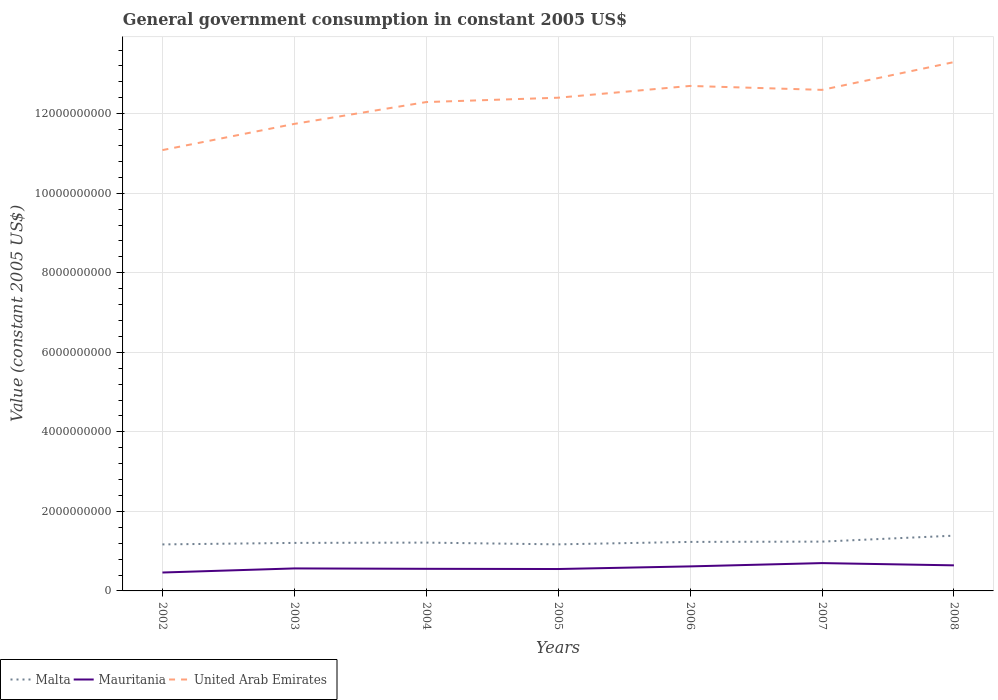Does the line corresponding to Malta intersect with the line corresponding to United Arab Emirates?
Make the answer very short. No. Across all years, what is the maximum government conusmption in Mauritania?
Offer a terse response. 4.63e+08. In which year was the government conusmption in United Arab Emirates maximum?
Your response must be concise. 2002. What is the total government conusmption in Mauritania in the graph?
Keep it short and to the point. 9.71e+06. What is the difference between the highest and the second highest government conusmption in United Arab Emirates?
Ensure brevity in your answer.  2.21e+09. What is the difference between the highest and the lowest government conusmption in Malta?
Ensure brevity in your answer.  3. Is the government conusmption in United Arab Emirates strictly greater than the government conusmption in Malta over the years?
Ensure brevity in your answer.  No. How many lines are there?
Provide a succinct answer. 3. Are the values on the major ticks of Y-axis written in scientific E-notation?
Offer a very short reply. No. Where does the legend appear in the graph?
Provide a short and direct response. Bottom left. How many legend labels are there?
Your answer should be compact. 3. How are the legend labels stacked?
Ensure brevity in your answer.  Horizontal. What is the title of the graph?
Give a very brief answer. General government consumption in constant 2005 US$. Does "Israel" appear as one of the legend labels in the graph?
Make the answer very short. No. What is the label or title of the Y-axis?
Make the answer very short. Value (constant 2005 US$). What is the Value (constant 2005 US$) of Malta in 2002?
Offer a very short reply. 1.17e+09. What is the Value (constant 2005 US$) of Mauritania in 2002?
Your response must be concise. 4.63e+08. What is the Value (constant 2005 US$) in United Arab Emirates in 2002?
Provide a succinct answer. 1.11e+1. What is the Value (constant 2005 US$) of Malta in 2003?
Your response must be concise. 1.21e+09. What is the Value (constant 2005 US$) in Mauritania in 2003?
Keep it short and to the point. 5.66e+08. What is the Value (constant 2005 US$) of United Arab Emirates in 2003?
Offer a terse response. 1.17e+1. What is the Value (constant 2005 US$) in Malta in 2004?
Provide a succinct answer. 1.21e+09. What is the Value (constant 2005 US$) in Mauritania in 2004?
Offer a very short reply. 5.56e+08. What is the Value (constant 2005 US$) of United Arab Emirates in 2004?
Provide a succinct answer. 1.23e+1. What is the Value (constant 2005 US$) in Malta in 2005?
Provide a short and direct response. 1.17e+09. What is the Value (constant 2005 US$) of Mauritania in 2005?
Provide a short and direct response. 5.51e+08. What is the Value (constant 2005 US$) of United Arab Emirates in 2005?
Keep it short and to the point. 1.24e+1. What is the Value (constant 2005 US$) in Malta in 2006?
Keep it short and to the point. 1.23e+09. What is the Value (constant 2005 US$) in Mauritania in 2006?
Your response must be concise. 6.17e+08. What is the Value (constant 2005 US$) in United Arab Emirates in 2006?
Offer a terse response. 1.27e+1. What is the Value (constant 2005 US$) in Malta in 2007?
Give a very brief answer. 1.24e+09. What is the Value (constant 2005 US$) in Mauritania in 2007?
Make the answer very short. 7.00e+08. What is the Value (constant 2005 US$) of United Arab Emirates in 2007?
Make the answer very short. 1.26e+1. What is the Value (constant 2005 US$) in Malta in 2008?
Ensure brevity in your answer.  1.39e+09. What is the Value (constant 2005 US$) of Mauritania in 2008?
Your answer should be very brief. 6.43e+08. What is the Value (constant 2005 US$) of United Arab Emirates in 2008?
Give a very brief answer. 1.33e+1. Across all years, what is the maximum Value (constant 2005 US$) in Malta?
Your answer should be very brief. 1.39e+09. Across all years, what is the maximum Value (constant 2005 US$) in Mauritania?
Ensure brevity in your answer.  7.00e+08. Across all years, what is the maximum Value (constant 2005 US$) of United Arab Emirates?
Give a very brief answer. 1.33e+1. Across all years, what is the minimum Value (constant 2005 US$) in Malta?
Ensure brevity in your answer.  1.17e+09. Across all years, what is the minimum Value (constant 2005 US$) of Mauritania?
Offer a very short reply. 4.63e+08. Across all years, what is the minimum Value (constant 2005 US$) of United Arab Emirates?
Provide a short and direct response. 1.11e+1. What is the total Value (constant 2005 US$) of Malta in the graph?
Your response must be concise. 8.62e+09. What is the total Value (constant 2005 US$) in Mauritania in the graph?
Your response must be concise. 4.09e+09. What is the total Value (constant 2005 US$) of United Arab Emirates in the graph?
Your answer should be very brief. 8.61e+1. What is the difference between the Value (constant 2005 US$) in Malta in 2002 and that in 2003?
Your response must be concise. -3.79e+07. What is the difference between the Value (constant 2005 US$) of Mauritania in 2002 and that in 2003?
Your answer should be compact. -1.03e+08. What is the difference between the Value (constant 2005 US$) of United Arab Emirates in 2002 and that in 2003?
Your answer should be very brief. -6.59e+08. What is the difference between the Value (constant 2005 US$) in Malta in 2002 and that in 2004?
Offer a very short reply. -4.53e+07. What is the difference between the Value (constant 2005 US$) of Mauritania in 2002 and that in 2004?
Give a very brief answer. -9.31e+07. What is the difference between the Value (constant 2005 US$) in United Arab Emirates in 2002 and that in 2004?
Keep it short and to the point. -1.21e+09. What is the difference between the Value (constant 2005 US$) of Malta in 2002 and that in 2005?
Provide a succinct answer. -1.22e+06. What is the difference between the Value (constant 2005 US$) of Mauritania in 2002 and that in 2005?
Keep it short and to the point. -8.77e+07. What is the difference between the Value (constant 2005 US$) in United Arab Emirates in 2002 and that in 2005?
Your answer should be compact. -1.32e+09. What is the difference between the Value (constant 2005 US$) in Malta in 2002 and that in 2006?
Keep it short and to the point. -6.31e+07. What is the difference between the Value (constant 2005 US$) in Mauritania in 2002 and that in 2006?
Offer a very short reply. -1.54e+08. What is the difference between the Value (constant 2005 US$) of United Arab Emirates in 2002 and that in 2006?
Provide a succinct answer. -1.61e+09. What is the difference between the Value (constant 2005 US$) in Malta in 2002 and that in 2007?
Offer a very short reply. -7.02e+07. What is the difference between the Value (constant 2005 US$) of Mauritania in 2002 and that in 2007?
Provide a succinct answer. -2.37e+08. What is the difference between the Value (constant 2005 US$) in United Arab Emirates in 2002 and that in 2007?
Keep it short and to the point. -1.51e+09. What is the difference between the Value (constant 2005 US$) of Malta in 2002 and that in 2008?
Your answer should be compact. -2.20e+08. What is the difference between the Value (constant 2005 US$) in Mauritania in 2002 and that in 2008?
Provide a short and direct response. -1.80e+08. What is the difference between the Value (constant 2005 US$) in United Arab Emirates in 2002 and that in 2008?
Your answer should be very brief. -2.21e+09. What is the difference between the Value (constant 2005 US$) in Malta in 2003 and that in 2004?
Make the answer very short. -7.48e+06. What is the difference between the Value (constant 2005 US$) in Mauritania in 2003 and that in 2004?
Your answer should be very brief. 9.71e+06. What is the difference between the Value (constant 2005 US$) in United Arab Emirates in 2003 and that in 2004?
Make the answer very short. -5.49e+08. What is the difference between the Value (constant 2005 US$) in Malta in 2003 and that in 2005?
Provide a succinct answer. 3.66e+07. What is the difference between the Value (constant 2005 US$) of Mauritania in 2003 and that in 2005?
Give a very brief answer. 1.52e+07. What is the difference between the Value (constant 2005 US$) in United Arab Emirates in 2003 and that in 2005?
Provide a short and direct response. -6.58e+08. What is the difference between the Value (constant 2005 US$) in Malta in 2003 and that in 2006?
Your answer should be compact. -2.52e+07. What is the difference between the Value (constant 2005 US$) in Mauritania in 2003 and that in 2006?
Make the answer very short. -5.08e+07. What is the difference between the Value (constant 2005 US$) in United Arab Emirates in 2003 and that in 2006?
Provide a short and direct response. -9.54e+08. What is the difference between the Value (constant 2005 US$) in Malta in 2003 and that in 2007?
Your response must be concise. -3.24e+07. What is the difference between the Value (constant 2005 US$) of Mauritania in 2003 and that in 2007?
Keep it short and to the point. -1.34e+08. What is the difference between the Value (constant 2005 US$) in United Arab Emirates in 2003 and that in 2007?
Provide a short and direct response. -8.55e+08. What is the difference between the Value (constant 2005 US$) of Malta in 2003 and that in 2008?
Your response must be concise. -1.82e+08. What is the difference between the Value (constant 2005 US$) in Mauritania in 2003 and that in 2008?
Offer a very short reply. -7.74e+07. What is the difference between the Value (constant 2005 US$) in United Arab Emirates in 2003 and that in 2008?
Provide a succinct answer. -1.55e+09. What is the difference between the Value (constant 2005 US$) of Malta in 2004 and that in 2005?
Provide a succinct answer. 4.41e+07. What is the difference between the Value (constant 2005 US$) in Mauritania in 2004 and that in 2005?
Offer a terse response. 5.46e+06. What is the difference between the Value (constant 2005 US$) in United Arab Emirates in 2004 and that in 2005?
Ensure brevity in your answer.  -1.09e+08. What is the difference between the Value (constant 2005 US$) of Malta in 2004 and that in 2006?
Provide a short and direct response. -1.77e+07. What is the difference between the Value (constant 2005 US$) of Mauritania in 2004 and that in 2006?
Your answer should be compact. -6.05e+07. What is the difference between the Value (constant 2005 US$) in United Arab Emirates in 2004 and that in 2006?
Your answer should be compact. -4.06e+08. What is the difference between the Value (constant 2005 US$) of Malta in 2004 and that in 2007?
Provide a short and direct response. -2.49e+07. What is the difference between the Value (constant 2005 US$) of Mauritania in 2004 and that in 2007?
Keep it short and to the point. -1.44e+08. What is the difference between the Value (constant 2005 US$) in United Arab Emirates in 2004 and that in 2007?
Ensure brevity in your answer.  -3.06e+08. What is the difference between the Value (constant 2005 US$) in Malta in 2004 and that in 2008?
Ensure brevity in your answer.  -1.75e+08. What is the difference between the Value (constant 2005 US$) of Mauritania in 2004 and that in 2008?
Give a very brief answer. -8.71e+07. What is the difference between the Value (constant 2005 US$) in United Arab Emirates in 2004 and that in 2008?
Offer a terse response. -1.00e+09. What is the difference between the Value (constant 2005 US$) in Malta in 2005 and that in 2006?
Give a very brief answer. -6.18e+07. What is the difference between the Value (constant 2005 US$) in Mauritania in 2005 and that in 2006?
Make the answer very short. -6.60e+07. What is the difference between the Value (constant 2005 US$) of United Arab Emirates in 2005 and that in 2006?
Provide a short and direct response. -2.96e+08. What is the difference between the Value (constant 2005 US$) of Malta in 2005 and that in 2007?
Keep it short and to the point. -6.90e+07. What is the difference between the Value (constant 2005 US$) in Mauritania in 2005 and that in 2007?
Ensure brevity in your answer.  -1.49e+08. What is the difference between the Value (constant 2005 US$) of United Arab Emirates in 2005 and that in 2007?
Your answer should be very brief. -1.97e+08. What is the difference between the Value (constant 2005 US$) of Malta in 2005 and that in 2008?
Your answer should be very brief. -2.19e+08. What is the difference between the Value (constant 2005 US$) in Mauritania in 2005 and that in 2008?
Provide a short and direct response. -9.26e+07. What is the difference between the Value (constant 2005 US$) of United Arab Emirates in 2005 and that in 2008?
Offer a very short reply. -8.96e+08. What is the difference between the Value (constant 2005 US$) of Malta in 2006 and that in 2007?
Make the answer very short. -7.18e+06. What is the difference between the Value (constant 2005 US$) of Mauritania in 2006 and that in 2007?
Offer a terse response. -8.31e+07. What is the difference between the Value (constant 2005 US$) of United Arab Emirates in 2006 and that in 2007?
Keep it short and to the point. 9.91e+07. What is the difference between the Value (constant 2005 US$) in Malta in 2006 and that in 2008?
Provide a short and direct response. -1.57e+08. What is the difference between the Value (constant 2005 US$) of Mauritania in 2006 and that in 2008?
Give a very brief answer. -2.66e+07. What is the difference between the Value (constant 2005 US$) in United Arab Emirates in 2006 and that in 2008?
Offer a very short reply. -5.99e+08. What is the difference between the Value (constant 2005 US$) of Malta in 2007 and that in 2008?
Provide a succinct answer. -1.50e+08. What is the difference between the Value (constant 2005 US$) in Mauritania in 2007 and that in 2008?
Offer a terse response. 5.65e+07. What is the difference between the Value (constant 2005 US$) in United Arab Emirates in 2007 and that in 2008?
Offer a very short reply. -6.98e+08. What is the difference between the Value (constant 2005 US$) of Malta in 2002 and the Value (constant 2005 US$) of Mauritania in 2003?
Your answer should be compact. 6.04e+08. What is the difference between the Value (constant 2005 US$) in Malta in 2002 and the Value (constant 2005 US$) in United Arab Emirates in 2003?
Keep it short and to the point. -1.06e+1. What is the difference between the Value (constant 2005 US$) of Mauritania in 2002 and the Value (constant 2005 US$) of United Arab Emirates in 2003?
Offer a very short reply. -1.13e+1. What is the difference between the Value (constant 2005 US$) in Malta in 2002 and the Value (constant 2005 US$) in Mauritania in 2004?
Make the answer very short. 6.13e+08. What is the difference between the Value (constant 2005 US$) in Malta in 2002 and the Value (constant 2005 US$) in United Arab Emirates in 2004?
Make the answer very short. -1.11e+1. What is the difference between the Value (constant 2005 US$) in Mauritania in 2002 and the Value (constant 2005 US$) in United Arab Emirates in 2004?
Your response must be concise. -1.18e+1. What is the difference between the Value (constant 2005 US$) in Malta in 2002 and the Value (constant 2005 US$) in Mauritania in 2005?
Ensure brevity in your answer.  6.19e+08. What is the difference between the Value (constant 2005 US$) in Malta in 2002 and the Value (constant 2005 US$) in United Arab Emirates in 2005?
Give a very brief answer. -1.12e+1. What is the difference between the Value (constant 2005 US$) in Mauritania in 2002 and the Value (constant 2005 US$) in United Arab Emirates in 2005?
Your answer should be very brief. -1.19e+1. What is the difference between the Value (constant 2005 US$) of Malta in 2002 and the Value (constant 2005 US$) of Mauritania in 2006?
Give a very brief answer. 5.53e+08. What is the difference between the Value (constant 2005 US$) of Malta in 2002 and the Value (constant 2005 US$) of United Arab Emirates in 2006?
Give a very brief answer. -1.15e+1. What is the difference between the Value (constant 2005 US$) of Mauritania in 2002 and the Value (constant 2005 US$) of United Arab Emirates in 2006?
Provide a succinct answer. -1.22e+1. What is the difference between the Value (constant 2005 US$) in Malta in 2002 and the Value (constant 2005 US$) in Mauritania in 2007?
Your answer should be compact. 4.70e+08. What is the difference between the Value (constant 2005 US$) of Malta in 2002 and the Value (constant 2005 US$) of United Arab Emirates in 2007?
Your answer should be compact. -1.14e+1. What is the difference between the Value (constant 2005 US$) of Mauritania in 2002 and the Value (constant 2005 US$) of United Arab Emirates in 2007?
Keep it short and to the point. -1.21e+1. What is the difference between the Value (constant 2005 US$) in Malta in 2002 and the Value (constant 2005 US$) in Mauritania in 2008?
Your answer should be compact. 5.26e+08. What is the difference between the Value (constant 2005 US$) in Malta in 2002 and the Value (constant 2005 US$) in United Arab Emirates in 2008?
Provide a succinct answer. -1.21e+1. What is the difference between the Value (constant 2005 US$) of Mauritania in 2002 and the Value (constant 2005 US$) of United Arab Emirates in 2008?
Provide a succinct answer. -1.28e+1. What is the difference between the Value (constant 2005 US$) in Malta in 2003 and the Value (constant 2005 US$) in Mauritania in 2004?
Your response must be concise. 6.51e+08. What is the difference between the Value (constant 2005 US$) of Malta in 2003 and the Value (constant 2005 US$) of United Arab Emirates in 2004?
Ensure brevity in your answer.  -1.11e+1. What is the difference between the Value (constant 2005 US$) in Mauritania in 2003 and the Value (constant 2005 US$) in United Arab Emirates in 2004?
Give a very brief answer. -1.17e+1. What is the difference between the Value (constant 2005 US$) of Malta in 2003 and the Value (constant 2005 US$) of Mauritania in 2005?
Make the answer very short. 6.57e+08. What is the difference between the Value (constant 2005 US$) in Malta in 2003 and the Value (constant 2005 US$) in United Arab Emirates in 2005?
Your answer should be very brief. -1.12e+1. What is the difference between the Value (constant 2005 US$) in Mauritania in 2003 and the Value (constant 2005 US$) in United Arab Emirates in 2005?
Make the answer very short. -1.18e+1. What is the difference between the Value (constant 2005 US$) of Malta in 2003 and the Value (constant 2005 US$) of Mauritania in 2006?
Provide a succinct answer. 5.91e+08. What is the difference between the Value (constant 2005 US$) of Malta in 2003 and the Value (constant 2005 US$) of United Arab Emirates in 2006?
Your answer should be very brief. -1.15e+1. What is the difference between the Value (constant 2005 US$) of Mauritania in 2003 and the Value (constant 2005 US$) of United Arab Emirates in 2006?
Give a very brief answer. -1.21e+1. What is the difference between the Value (constant 2005 US$) of Malta in 2003 and the Value (constant 2005 US$) of Mauritania in 2007?
Make the answer very short. 5.08e+08. What is the difference between the Value (constant 2005 US$) in Malta in 2003 and the Value (constant 2005 US$) in United Arab Emirates in 2007?
Keep it short and to the point. -1.14e+1. What is the difference between the Value (constant 2005 US$) in Mauritania in 2003 and the Value (constant 2005 US$) in United Arab Emirates in 2007?
Ensure brevity in your answer.  -1.20e+1. What is the difference between the Value (constant 2005 US$) of Malta in 2003 and the Value (constant 2005 US$) of Mauritania in 2008?
Provide a succinct answer. 5.64e+08. What is the difference between the Value (constant 2005 US$) in Malta in 2003 and the Value (constant 2005 US$) in United Arab Emirates in 2008?
Give a very brief answer. -1.21e+1. What is the difference between the Value (constant 2005 US$) in Mauritania in 2003 and the Value (constant 2005 US$) in United Arab Emirates in 2008?
Your answer should be very brief. -1.27e+1. What is the difference between the Value (constant 2005 US$) of Malta in 2004 and the Value (constant 2005 US$) of Mauritania in 2005?
Your answer should be compact. 6.64e+08. What is the difference between the Value (constant 2005 US$) of Malta in 2004 and the Value (constant 2005 US$) of United Arab Emirates in 2005?
Make the answer very short. -1.12e+1. What is the difference between the Value (constant 2005 US$) of Mauritania in 2004 and the Value (constant 2005 US$) of United Arab Emirates in 2005?
Make the answer very short. -1.18e+1. What is the difference between the Value (constant 2005 US$) of Malta in 2004 and the Value (constant 2005 US$) of Mauritania in 2006?
Make the answer very short. 5.98e+08. What is the difference between the Value (constant 2005 US$) in Malta in 2004 and the Value (constant 2005 US$) in United Arab Emirates in 2006?
Offer a terse response. -1.15e+1. What is the difference between the Value (constant 2005 US$) in Mauritania in 2004 and the Value (constant 2005 US$) in United Arab Emirates in 2006?
Give a very brief answer. -1.21e+1. What is the difference between the Value (constant 2005 US$) of Malta in 2004 and the Value (constant 2005 US$) of Mauritania in 2007?
Make the answer very short. 5.15e+08. What is the difference between the Value (constant 2005 US$) of Malta in 2004 and the Value (constant 2005 US$) of United Arab Emirates in 2007?
Make the answer very short. -1.14e+1. What is the difference between the Value (constant 2005 US$) in Mauritania in 2004 and the Value (constant 2005 US$) in United Arab Emirates in 2007?
Provide a short and direct response. -1.20e+1. What is the difference between the Value (constant 2005 US$) of Malta in 2004 and the Value (constant 2005 US$) of Mauritania in 2008?
Your answer should be compact. 5.72e+08. What is the difference between the Value (constant 2005 US$) of Malta in 2004 and the Value (constant 2005 US$) of United Arab Emirates in 2008?
Make the answer very short. -1.21e+1. What is the difference between the Value (constant 2005 US$) in Mauritania in 2004 and the Value (constant 2005 US$) in United Arab Emirates in 2008?
Offer a terse response. -1.27e+1. What is the difference between the Value (constant 2005 US$) of Malta in 2005 and the Value (constant 2005 US$) of Mauritania in 2006?
Give a very brief answer. 5.54e+08. What is the difference between the Value (constant 2005 US$) of Malta in 2005 and the Value (constant 2005 US$) of United Arab Emirates in 2006?
Your response must be concise. -1.15e+1. What is the difference between the Value (constant 2005 US$) in Mauritania in 2005 and the Value (constant 2005 US$) in United Arab Emirates in 2006?
Keep it short and to the point. -1.21e+1. What is the difference between the Value (constant 2005 US$) of Malta in 2005 and the Value (constant 2005 US$) of Mauritania in 2007?
Keep it short and to the point. 4.71e+08. What is the difference between the Value (constant 2005 US$) of Malta in 2005 and the Value (constant 2005 US$) of United Arab Emirates in 2007?
Your response must be concise. -1.14e+1. What is the difference between the Value (constant 2005 US$) of Mauritania in 2005 and the Value (constant 2005 US$) of United Arab Emirates in 2007?
Provide a short and direct response. -1.20e+1. What is the difference between the Value (constant 2005 US$) in Malta in 2005 and the Value (constant 2005 US$) in Mauritania in 2008?
Keep it short and to the point. 5.28e+08. What is the difference between the Value (constant 2005 US$) of Malta in 2005 and the Value (constant 2005 US$) of United Arab Emirates in 2008?
Offer a terse response. -1.21e+1. What is the difference between the Value (constant 2005 US$) in Mauritania in 2005 and the Value (constant 2005 US$) in United Arab Emirates in 2008?
Keep it short and to the point. -1.27e+1. What is the difference between the Value (constant 2005 US$) in Malta in 2006 and the Value (constant 2005 US$) in Mauritania in 2007?
Provide a succinct answer. 5.33e+08. What is the difference between the Value (constant 2005 US$) of Malta in 2006 and the Value (constant 2005 US$) of United Arab Emirates in 2007?
Ensure brevity in your answer.  -1.14e+1. What is the difference between the Value (constant 2005 US$) in Mauritania in 2006 and the Value (constant 2005 US$) in United Arab Emirates in 2007?
Your response must be concise. -1.20e+1. What is the difference between the Value (constant 2005 US$) in Malta in 2006 and the Value (constant 2005 US$) in Mauritania in 2008?
Your response must be concise. 5.89e+08. What is the difference between the Value (constant 2005 US$) in Malta in 2006 and the Value (constant 2005 US$) in United Arab Emirates in 2008?
Provide a succinct answer. -1.21e+1. What is the difference between the Value (constant 2005 US$) of Mauritania in 2006 and the Value (constant 2005 US$) of United Arab Emirates in 2008?
Your answer should be very brief. -1.27e+1. What is the difference between the Value (constant 2005 US$) of Malta in 2007 and the Value (constant 2005 US$) of Mauritania in 2008?
Give a very brief answer. 5.97e+08. What is the difference between the Value (constant 2005 US$) in Malta in 2007 and the Value (constant 2005 US$) in United Arab Emirates in 2008?
Make the answer very short. -1.21e+1. What is the difference between the Value (constant 2005 US$) in Mauritania in 2007 and the Value (constant 2005 US$) in United Arab Emirates in 2008?
Give a very brief answer. -1.26e+1. What is the average Value (constant 2005 US$) in Malta per year?
Provide a succinct answer. 1.23e+09. What is the average Value (constant 2005 US$) in Mauritania per year?
Give a very brief answer. 5.85e+08. What is the average Value (constant 2005 US$) in United Arab Emirates per year?
Make the answer very short. 1.23e+1. In the year 2002, what is the difference between the Value (constant 2005 US$) in Malta and Value (constant 2005 US$) in Mauritania?
Offer a very short reply. 7.07e+08. In the year 2002, what is the difference between the Value (constant 2005 US$) in Malta and Value (constant 2005 US$) in United Arab Emirates?
Your answer should be very brief. -9.91e+09. In the year 2002, what is the difference between the Value (constant 2005 US$) in Mauritania and Value (constant 2005 US$) in United Arab Emirates?
Offer a terse response. -1.06e+1. In the year 2003, what is the difference between the Value (constant 2005 US$) of Malta and Value (constant 2005 US$) of Mauritania?
Offer a terse response. 6.42e+08. In the year 2003, what is the difference between the Value (constant 2005 US$) in Malta and Value (constant 2005 US$) in United Arab Emirates?
Your response must be concise. -1.05e+1. In the year 2003, what is the difference between the Value (constant 2005 US$) of Mauritania and Value (constant 2005 US$) of United Arab Emirates?
Your answer should be compact. -1.12e+1. In the year 2004, what is the difference between the Value (constant 2005 US$) of Malta and Value (constant 2005 US$) of Mauritania?
Offer a very short reply. 6.59e+08. In the year 2004, what is the difference between the Value (constant 2005 US$) of Malta and Value (constant 2005 US$) of United Arab Emirates?
Your response must be concise. -1.11e+1. In the year 2004, what is the difference between the Value (constant 2005 US$) of Mauritania and Value (constant 2005 US$) of United Arab Emirates?
Make the answer very short. -1.17e+1. In the year 2005, what is the difference between the Value (constant 2005 US$) of Malta and Value (constant 2005 US$) of Mauritania?
Your answer should be compact. 6.20e+08. In the year 2005, what is the difference between the Value (constant 2005 US$) of Malta and Value (constant 2005 US$) of United Arab Emirates?
Keep it short and to the point. -1.12e+1. In the year 2005, what is the difference between the Value (constant 2005 US$) in Mauritania and Value (constant 2005 US$) in United Arab Emirates?
Ensure brevity in your answer.  -1.19e+1. In the year 2006, what is the difference between the Value (constant 2005 US$) of Malta and Value (constant 2005 US$) of Mauritania?
Your answer should be very brief. 6.16e+08. In the year 2006, what is the difference between the Value (constant 2005 US$) in Malta and Value (constant 2005 US$) in United Arab Emirates?
Offer a very short reply. -1.15e+1. In the year 2006, what is the difference between the Value (constant 2005 US$) in Mauritania and Value (constant 2005 US$) in United Arab Emirates?
Your response must be concise. -1.21e+1. In the year 2007, what is the difference between the Value (constant 2005 US$) of Malta and Value (constant 2005 US$) of Mauritania?
Your answer should be compact. 5.40e+08. In the year 2007, what is the difference between the Value (constant 2005 US$) of Malta and Value (constant 2005 US$) of United Arab Emirates?
Your answer should be compact. -1.14e+1. In the year 2007, what is the difference between the Value (constant 2005 US$) of Mauritania and Value (constant 2005 US$) of United Arab Emirates?
Keep it short and to the point. -1.19e+1. In the year 2008, what is the difference between the Value (constant 2005 US$) of Malta and Value (constant 2005 US$) of Mauritania?
Your answer should be very brief. 7.46e+08. In the year 2008, what is the difference between the Value (constant 2005 US$) in Malta and Value (constant 2005 US$) in United Arab Emirates?
Provide a short and direct response. -1.19e+1. In the year 2008, what is the difference between the Value (constant 2005 US$) of Mauritania and Value (constant 2005 US$) of United Arab Emirates?
Offer a very short reply. -1.27e+1. What is the ratio of the Value (constant 2005 US$) in Malta in 2002 to that in 2003?
Offer a terse response. 0.97. What is the ratio of the Value (constant 2005 US$) of Mauritania in 2002 to that in 2003?
Your answer should be very brief. 0.82. What is the ratio of the Value (constant 2005 US$) in United Arab Emirates in 2002 to that in 2003?
Provide a short and direct response. 0.94. What is the ratio of the Value (constant 2005 US$) in Malta in 2002 to that in 2004?
Provide a short and direct response. 0.96. What is the ratio of the Value (constant 2005 US$) of Mauritania in 2002 to that in 2004?
Make the answer very short. 0.83. What is the ratio of the Value (constant 2005 US$) of United Arab Emirates in 2002 to that in 2004?
Give a very brief answer. 0.9. What is the ratio of the Value (constant 2005 US$) in Mauritania in 2002 to that in 2005?
Offer a terse response. 0.84. What is the ratio of the Value (constant 2005 US$) in United Arab Emirates in 2002 to that in 2005?
Your response must be concise. 0.89. What is the ratio of the Value (constant 2005 US$) in Malta in 2002 to that in 2006?
Your answer should be very brief. 0.95. What is the ratio of the Value (constant 2005 US$) of Mauritania in 2002 to that in 2006?
Keep it short and to the point. 0.75. What is the ratio of the Value (constant 2005 US$) in United Arab Emirates in 2002 to that in 2006?
Keep it short and to the point. 0.87. What is the ratio of the Value (constant 2005 US$) in Malta in 2002 to that in 2007?
Provide a short and direct response. 0.94. What is the ratio of the Value (constant 2005 US$) in Mauritania in 2002 to that in 2007?
Keep it short and to the point. 0.66. What is the ratio of the Value (constant 2005 US$) of United Arab Emirates in 2002 to that in 2007?
Offer a terse response. 0.88. What is the ratio of the Value (constant 2005 US$) in Malta in 2002 to that in 2008?
Your answer should be compact. 0.84. What is the ratio of the Value (constant 2005 US$) of Mauritania in 2002 to that in 2008?
Keep it short and to the point. 0.72. What is the ratio of the Value (constant 2005 US$) in United Arab Emirates in 2002 to that in 2008?
Your response must be concise. 0.83. What is the ratio of the Value (constant 2005 US$) in Mauritania in 2003 to that in 2004?
Offer a very short reply. 1.02. What is the ratio of the Value (constant 2005 US$) in United Arab Emirates in 2003 to that in 2004?
Offer a terse response. 0.96. What is the ratio of the Value (constant 2005 US$) in Malta in 2003 to that in 2005?
Your answer should be compact. 1.03. What is the ratio of the Value (constant 2005 US$) in Mauritania in 2003 to that in 2005?
Your response must be concise. 1.03. What is the ratio of the Value (constant 2005 US$) in United Arab Emirates in 2003 to that in 2005?
Make the answer very short. 0.95. What is the ratio of the Value (constant 2005 US$) in Malta in 2003 to that in 2006?
Offer a very short reply. 0.98. What is the ratio of the Value (constant 2005 US$) in Mauritania in 2003 to that in 2006?
Provide a succinct answer. 0.92. What is the ratio of the Value (constant 2005 US$) in United Arab Emirates in 2003 to that in 2006?
Provide a short and direct response. 0.92. What is the ratio of the Value (constant 2005 US$) of Malta in 2003 to that in 2007?
Ensure brevity in your answer.  0.97. What is the ratio of the Value (constant 2005 US$) in Mauritania in 2003 to that in 2007?
Offer a very short reply. 0.81. What is the ratio of the Value (constant 2005 US$) in United Arab Emirates in 2003 to that in 2007?
Offer a terse response. 0.93. What is the ratio of the Value (constant 2005 US$) of Malta in 2003 to that in 2008?
Give a very brief answer. 0.87. What is the ratio of the Value (constant 2005 US$) of Mauritania in 2003 to that in 2008?
Your answer should be compact. 0.88. What is the ratio of the Value (constant 2005 US$) of United Arab Emirates in 2003 to that in 2008?
Your answer should be very brief. 0.88. What is the ratio of the Value (constant 2005 US$) in Malta in 2004 to that in 2005?
Provide a succinct answer. 1.04. What is the ratio of the Value (constant 2005 US$) in Mauritania in 2004 to that in 2005?
Your answer should be very brief. 1.01. What is the ratio of the Value (constant 2005 US$) in United Arab Emirates in 2004 to that in 2005?
Offer a terse response. 0.99. What is the ratio of the Value (constant 2005 US$) of Malta in 2004 to that in 2006?
Offer a terse response. 0.99. What is the ratio of the Value (constant 2005 US$) of Mauritania in 2004 to that in 2006?
Offer a very short reply. 0.9. What is the ratio of the Value (constant 2005 US$) in United Arab Emirates in 2004 to that in 2006?
Offer a very short reply. 0.97. What is the ratio of the Value (constant 2005 US$) of Malta in 2004 to that in 2007?
Ensure brevity in your answer.  0.98. What is the ratio of the Value (constant 2005 US$) in Mauritania in 2004 to that in 2007?
Provide a short and direct response. 0.79. What is the ratio of the Value (constant 2005 US$) of United Arab Emirates in 2004 to that in 2007?
Your answer should be very brief. 0.98. What is the ratio of the Value (constant 2005 US$) of Malta in 2004 to that in 2008?
Make the answer very short. 0.87. What is the ratio of the Value (constant 2005 US$) of Mauritania in 2004 to that in 2008?
Offer a very short reply. 0.86. What is the ratio of the Value (constant 2005 US$) in United Arab Emirates in 2004 to that in 2008?
Provide a short and direct response. 0.92. What is the ratio of the Value (constant 2005 US$) of Malta in 2005 to that in 2006?
Your response must be concise. 0.95. What is the ratio of the Value (constant 2005 US$) in Mauritania in 2005 to that in 2006?
Give a very brief answer. 0.89. What is the ratio of the Value (constant 2005 US$) of United Arab Emirates in 2005 to that in 2006?
Give a very brief answer. 0.98. What is the ratio of the Value (constant 2005 US$) in Malta in 2005 to that in 2007?
Ensure brevity in your answer.  0.94. What is the ratio of the Value (constant 2005 US$) in Mauritania in 2005 to that in 2007?
Your answer should be compact. 0.79. What is the ratio of the Value (constant 2005 US$) of United Arab Emirates in 2005 to that in 2007?
Keep it short and to the point. 0.98. What is the ratio of the Value (constant 2005 US$) of Malta in 2005 to that in 2008?
Offer a terse response. 0.84. What is the ratio of the Value (constant 2005 US$) in Mauritania in 2005 to that in 2008?
Offer a very short reply. 0.86. What is the ratio of the Value (constant 2005 US$) in United Arab Emirates in 2005 to that in 2008?
Keep it short and to the point. 0.93. What is the ratio of the Value (constant 2005 US$) in Mauritania in 2006 to that in 2007?
Give a very brief answer. 0.88. What is the ratio of the Value (constant 2005 US$) of United Arab Emirates in 2006 to that in 2007?
Your answer should be very brief. 1.01. What is the ratio of the Value (constant 2005 US$) of Malta in 2006 to that in 2008?
Your answer should be compact. 0.89. What is the ratio of the Value (constant 2005 US$) in Mauritania in 2006 to that in 2008?
Ensure brevity in your answer.  0.96. What is the ratio of the Value (constant 2005 US$) of United Arab Emirates in 2006 to that in 2008?
Offer a terse response. 0.95. What is the ratio of the Value (constant 2005 US$) of Malta in 2007 to that in 2008?
Offer a terse response. 0.89. What is the ratio of the Value (constant 2005 US$) in Mauritania in 2007 to that in 2008?
Ensure brevity in your answer.  1.09. What is the ratio of the Value (constant 2005 US$) in United Arab Emirates in 2007 to that in 2008?
Offer a very short reply. 0.95. What is the difference between the highest and the second highest Value (constant 2005 US$) of Malta?
Your answer should be very brief. 1.50e+08. What is the difference between the highest and the second highest Value (constant 2005 US$) of Mauritania?
Offer a very short reply. 5.65e+07. What is the difference between the highest and the second highest Value (constant 2005 US$) in United Arab Emirates?
Provide a succinct answer. 5.99e+08. What is the difference between the highest and the lowest Value (constant 2005 US$) in Malta?
Your answer should be compact. 2.20e+08. What is the difference between the highest and the lowest Value (constant 2005 US$) in Mauritania?
Your answer should be very brief. 2.37e+08. What is the difference between the highest and the lowest Value (constant 2005 US$) in United Arab Emirates?
Give a very brief answer. 2.21e+09. 